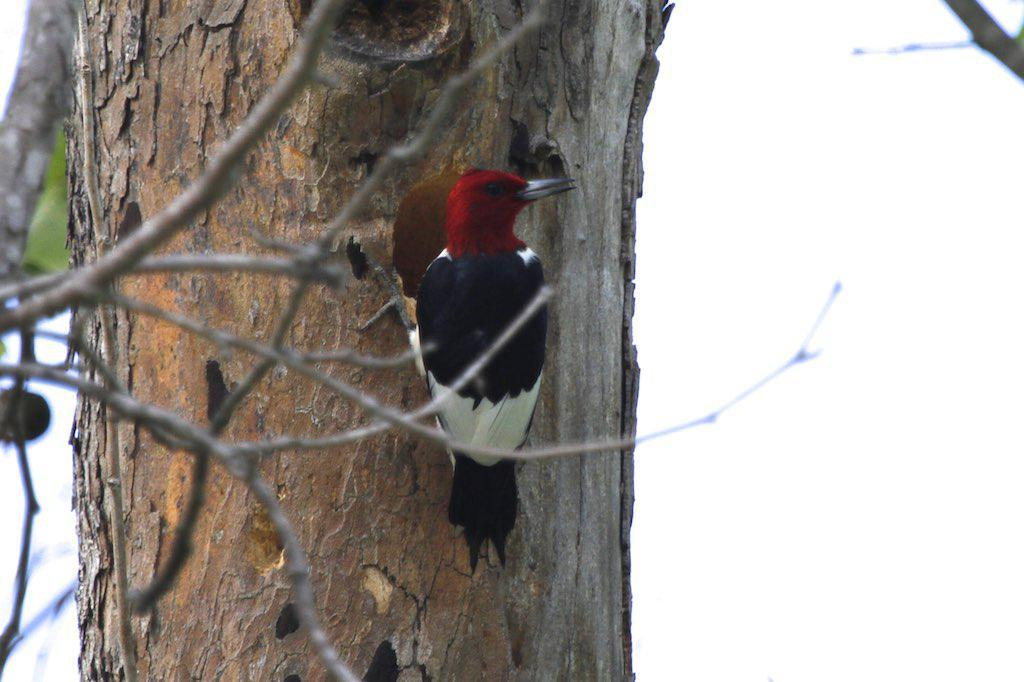What is the main subject in the middle of the image? There is a tree in the middle of the image. Are there any animals present in the image? Yes, there is a bird on the tree. What can be seen behind the tree in the image? The sky is visible behind the tree. How many brothers are visible in the image? There are no brothers present in the image. What type of base is supporting the tree in the image? The tree is not shown to be supported by any base in the image. 